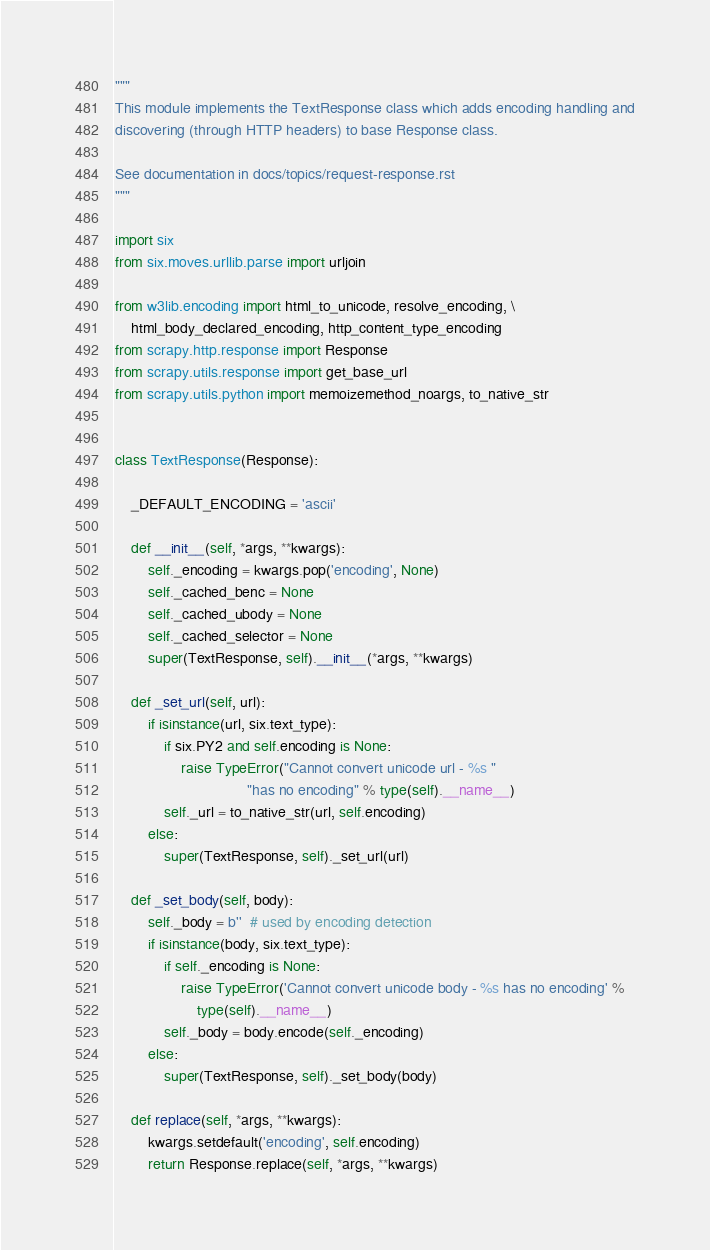<code> <loc_0><loc_0><loc_500><loc_500><_Python_>"""
This module implements the TextResponse class which adds encoding handling and
discovering (through HTTP headers) to base Response class.

See documentation in docs/topics/request-response.rst
"""

import six
from six.moves.urllib.parse import urljoin

from w3lib.encoding import html_to_unicode, resolve_encoding, \
    html_body_declared_encoding, http_content_type_encoding
from scrapy.http.response import Response
from scrapy.utils.response import get_base_url
from scrapy.utils.python import memoizemethod_noargs, to_native_str


class TextResponse(Response):

    _DEFAULT_ENCODING = 'ascii'

    def __init__(self, *args, **kwargs):
        self._encoding = kwargs.pop('encoding', None)
        self._cached_benc = None
        self._cached_ubody = None
        self._cached_selector = None
        super(TextResponse, self).__init__(*args, **kwargs)

    def _set_url(self, url):
        if isinstance(url, six.text_type):
            if six.PY2 and self.encoding is None:
                raise TypeError("Cannot convert unicode url - %s "
                                "has no encoding" % type(self).__name__)
            self._url = to_native_str(url, self.encoding)
        else:
            super(TextResponse, self)._set_url(url)

    def _set_body(self, body):
        self._body = b''  # used by encoding detection
        if isinstance(body, six.text_type):
            if self._encoding is None:
                raise TypeError('Cannot convert unicode body - %s has no encoding' %
                    type(self).__name__)
            self._body = body.encode(self._encoding)
        else:
            super(TextResponse, self)._set_body(body)

    def replace(self, *args, **kwargs):
        kwargs.setdefault('encoding', self.encoding)
        return Response.replace(self, *args, **kwargs)
</code> 